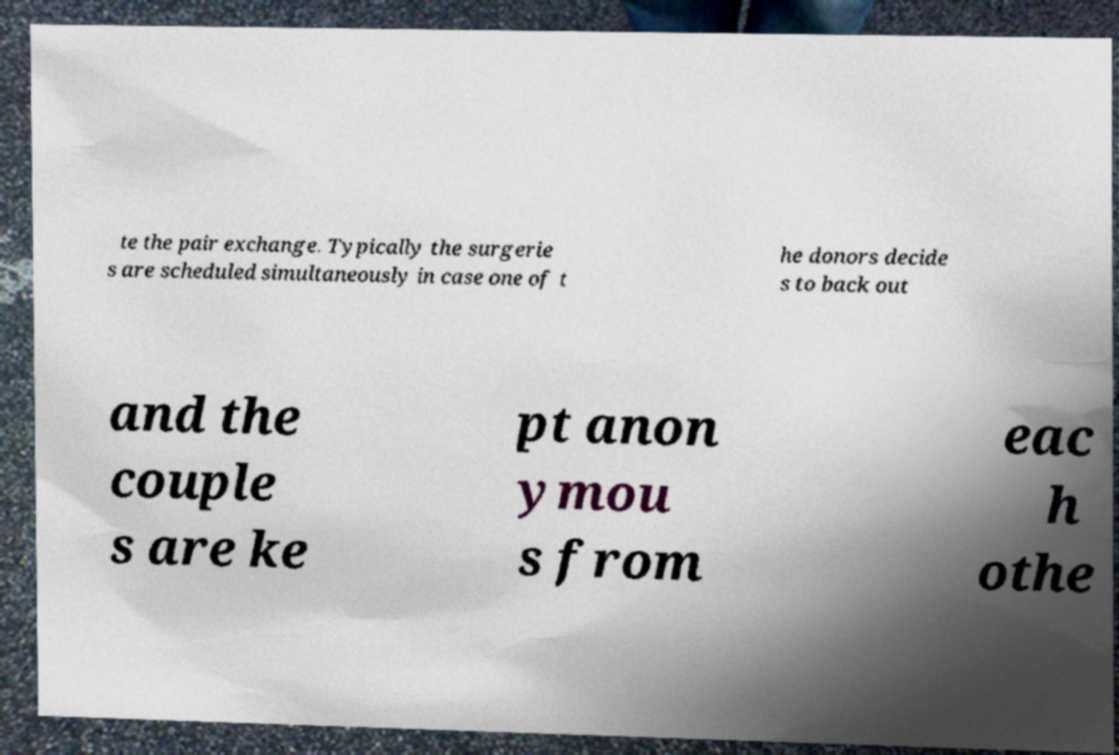I need the written content from this picture converted into text. Can you do that? te the pair exchange. Typically the surgerie s are scheduled simultaneously in case one of t he donors decide s to back out and the couple s are ke pt anon ymou s from eac h othe 